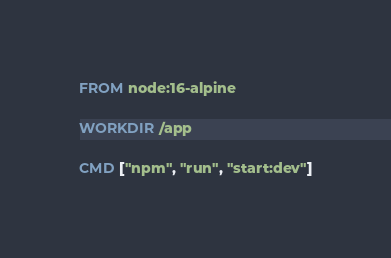<code> <loc_0><loc_0><loc_500><loc_500><_Dockerfile_>FROM node:16-alpine

WORKDIR /app

CMD ["npm", "run", "start:dev"]</code> 